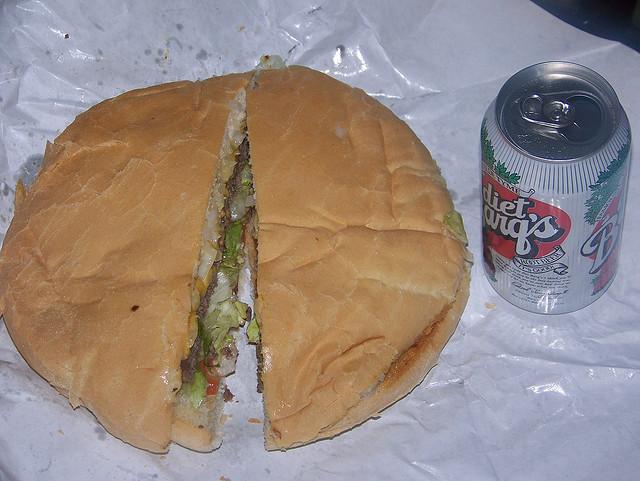Has the soda can been opened?
Concise answer only. Yes. Has the sandwich been cut?
Concise answer only. Yes. What type of sandwich is this?
Short answer required. Hamburger. 